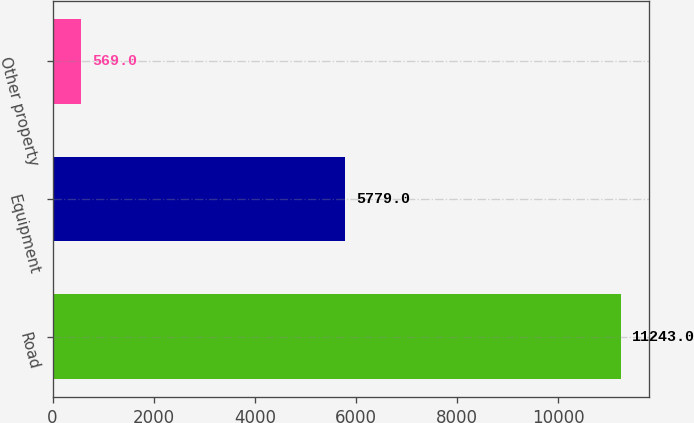Convert chart to OTSL. <chart><loc_0><loc_0><loc_500><loc_500><bar_chart><fcel>Road<fcel>Equipment<fcel>Other property<nl><fcel>11243<fcel>5779<fcel>569<nl></chart> 